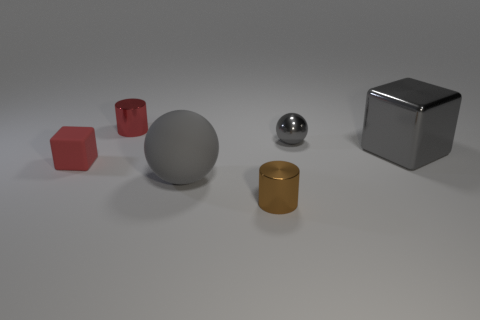Is there a shiny sphere that has the same size as the rubber cube?
Your answer should be very brief. Yes. What is the material of the gray thing to the left of the tiny shiny cylinder in front of the big gray thing that is right of the large gray rubber ball?
Your response must be concise. Rubber. Are there the same number of large gray spheres right of the big rubber object and big brown rubber things?
Offer a very short reply. Yes. Do the cube that is on the left side of the large gray rubber object and the large thing that is on the left side of the large gray block have the same material?
Your answer should be compact. Yes. What number of things are either large brown metallic cylinders or things behind the large gray matte sphere?
Provide a short and direct response. 4. Is there another thing of the same shape as the tiny brown metal thing?
Keep it short and to the point. Yes. There is a block that is on the right side of the gray sphere in front of the red thing that is in front of the small red cylinder; what size is it?
Provide a short and direct response. Large. Are there the same number of cubes on the left side of the red rubber object and big metallic things that are behind the large block?
Give a very brief answer. Yes. What size is the red cylinder that is the same material as the brown thing?
Keep it short and to the point. Small. The large rubber ball has what color?
Provide a succinct answer. Gray. 